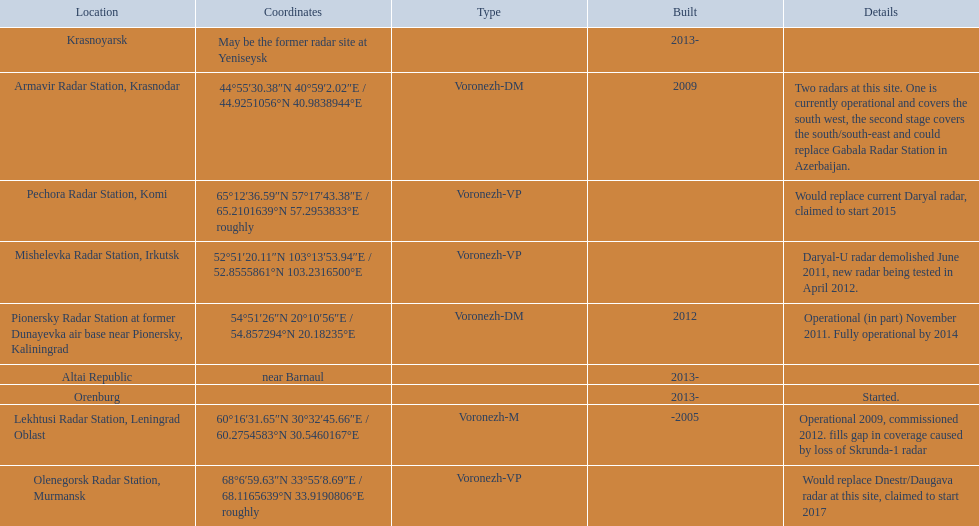Voronezh radar has locations where? Lekhtusi Radar Station, Leningrad Oblast, Armavir Radar Station, Krasnodar, Pionersky Radar Station at former Dunayevka air base near Pionersky, Kaliningrad, Mishelevka Radar Station, Irkutsk, Pechora Radar Station, Komi, Olenegorsk Radar Station, Murmansk, Krasnoyarsk, Altai Republic, Orenburg. Which of these locations have know coordinates? Lekhtusi Radar Station, Leningrad Oblast, Armavir Radar Station, Krasnodar, Pionersky Radar Station at former Dunayevka air base near Pionersky, Kaliningrad, Mishelevka Radar Station, Irkutsk, Pechora Radar Station, Komi, Olenegorsk Radar Station, Murmansk. Which of these locations has coordinates of 60deg16'31.65''n 30deg32'45.66''e / 60.2754583degn 30.5460167dege? Lekhtusi Radar Station, Leningrad Oblast. 